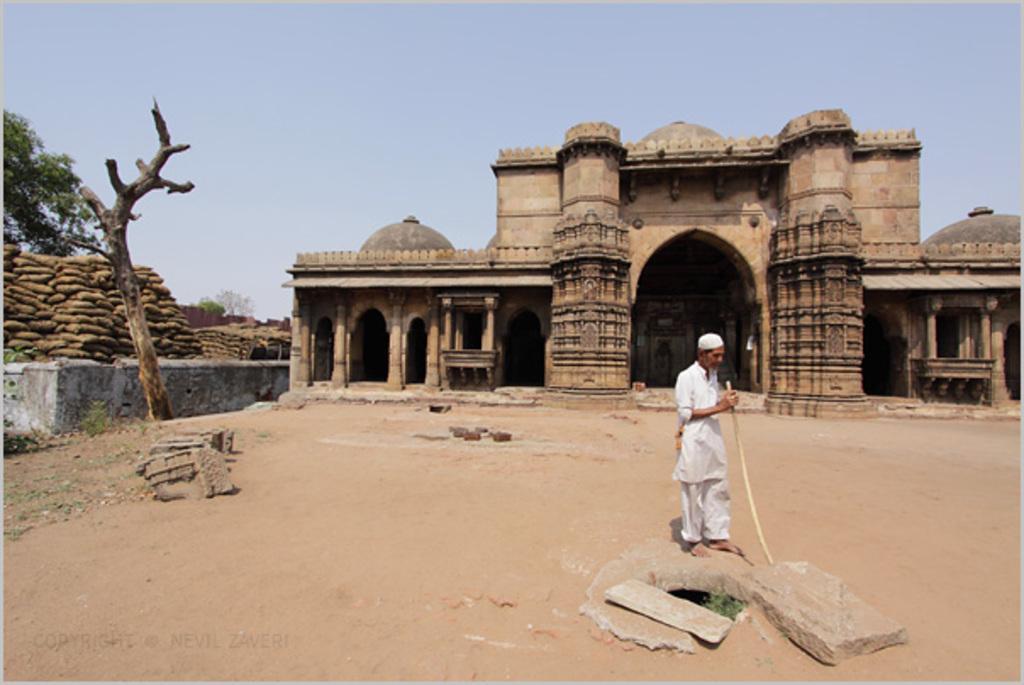Can you describe this image briefly? In this image I can see the person standing and holding the stick and the person is wearing white color dress. Background I can see the building in brown color, I can also see few objects in brown color, trees in green color and the sky is in blue color. 